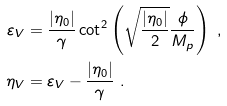<formula> <loc_0><loc_0><loc_500><loc_500>\varepsilon _ { V } & = \frac { | \eta _ { 0 } | } { \gamma } \cot ^ { 2 } \left ( \sqrt { \frac { | \eta _ { 0 } | } { 2 } } \frac { \phi } { M _ { p } } \right ) \ , \\ \eta _ { V } & = \varepsilon _ { V } - \frac { | \eta _ { 0 } | } { \gamma } \ .</formula> 